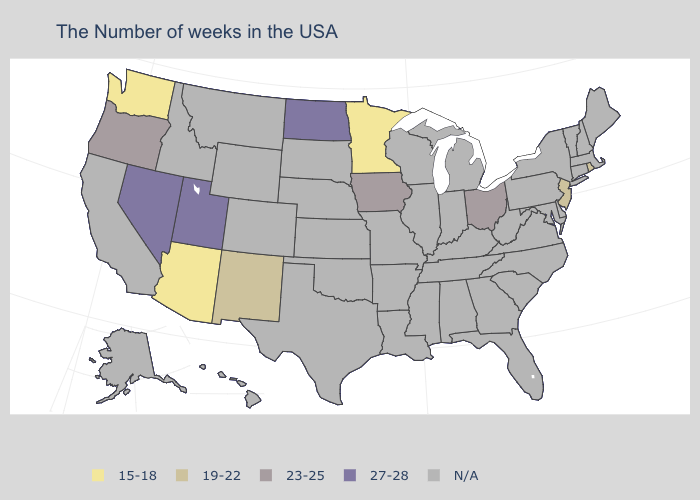Does the first symbol in the legend represent the smallest category?
Be succinct. Yes. What is the highest value in the West ?
Concise answer only. 27-28. What is the value of Kansas?
Be succinct. N/A. What is the highest value in the MidWest ?
Write a very short answer. 27-28. Among the states that border Connecticut , which have the lowest value?
Give a very brief answer. Rhode Island. What is the value of Pennsylvania?
Concise answer only. N/A. Name the states that have a value in the range 19-22?
Concise answer only. Rhode Island, New Jersey, New Mexico. What is the value of Florida?
Write a very short answer. N/A. What is the lowest value in states that border Massachusetts?
Give a very brief answer. 19-22. Which states have the highest value in the USA?
Concise answer only. North Dakota, Utah, Nevada. Among the states that border California , which have the highest value?
Quick response, please. Nevada. What is the highest value in the West ?
Be succinct. 27-28. 